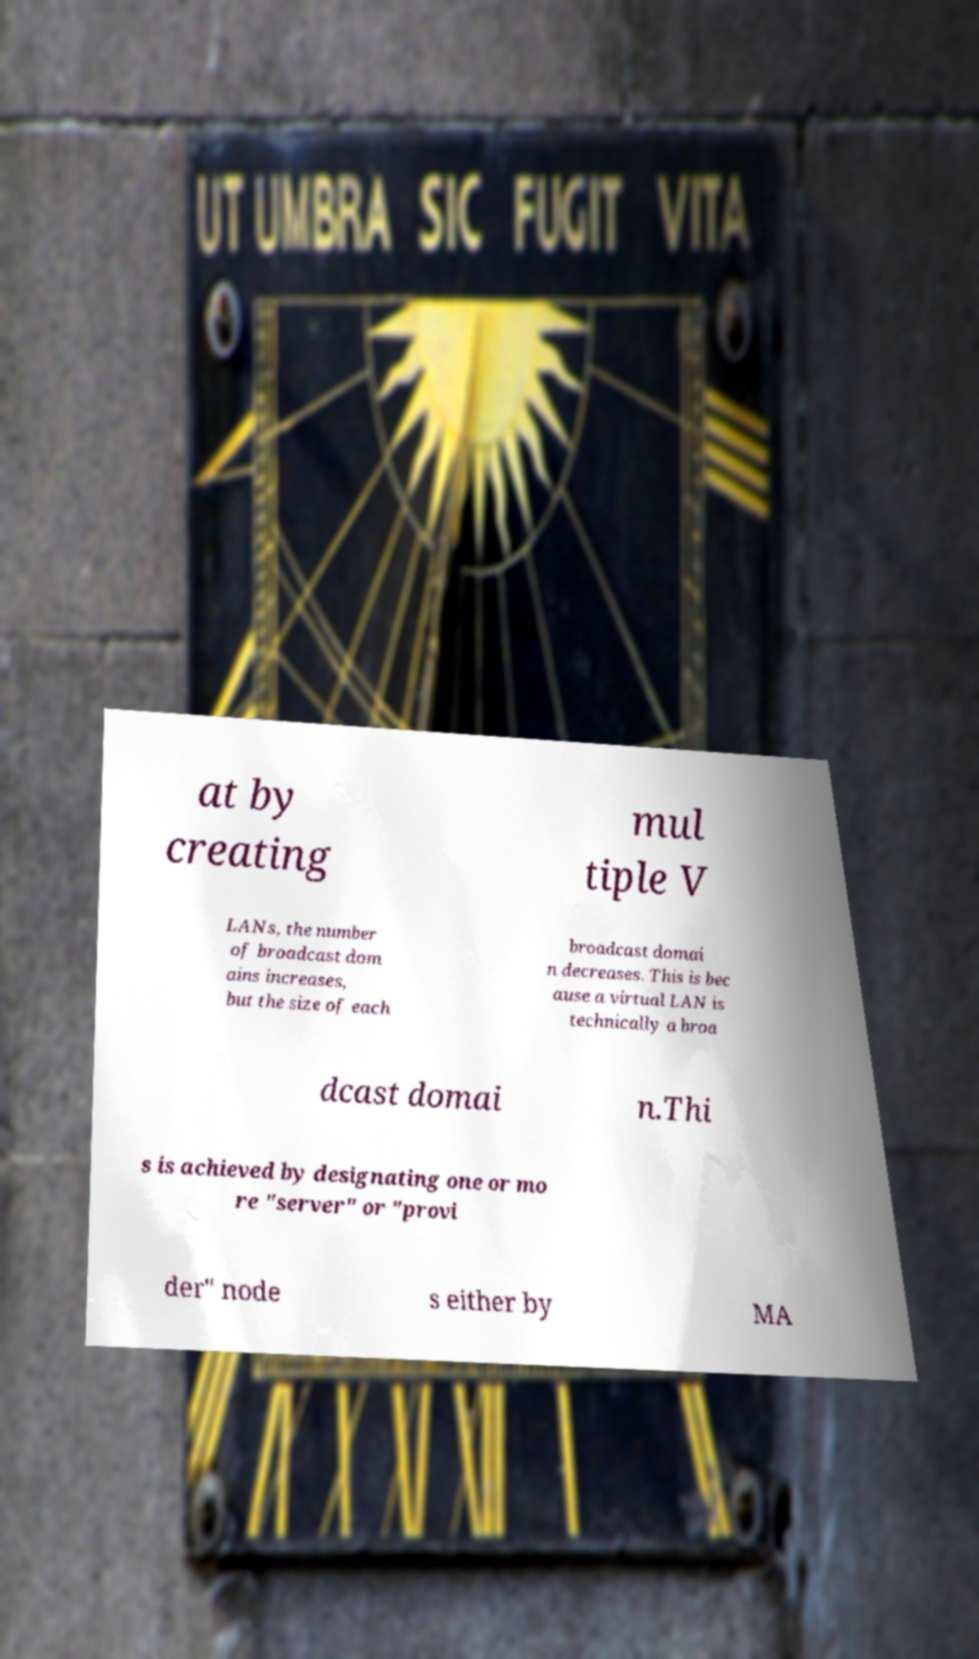For documentation purposes, I need the text within this image transcribed. Could you provide that? at by creating mul tiple V LANs, the number of broadcast dom ains increases, but the size of each broadcast domai n decreases. This is bec ause a virtual LAN is technically a broa dcast domai n.Thi s is achieved by designating one or mo re "server" or "provi der" node s either by MA 